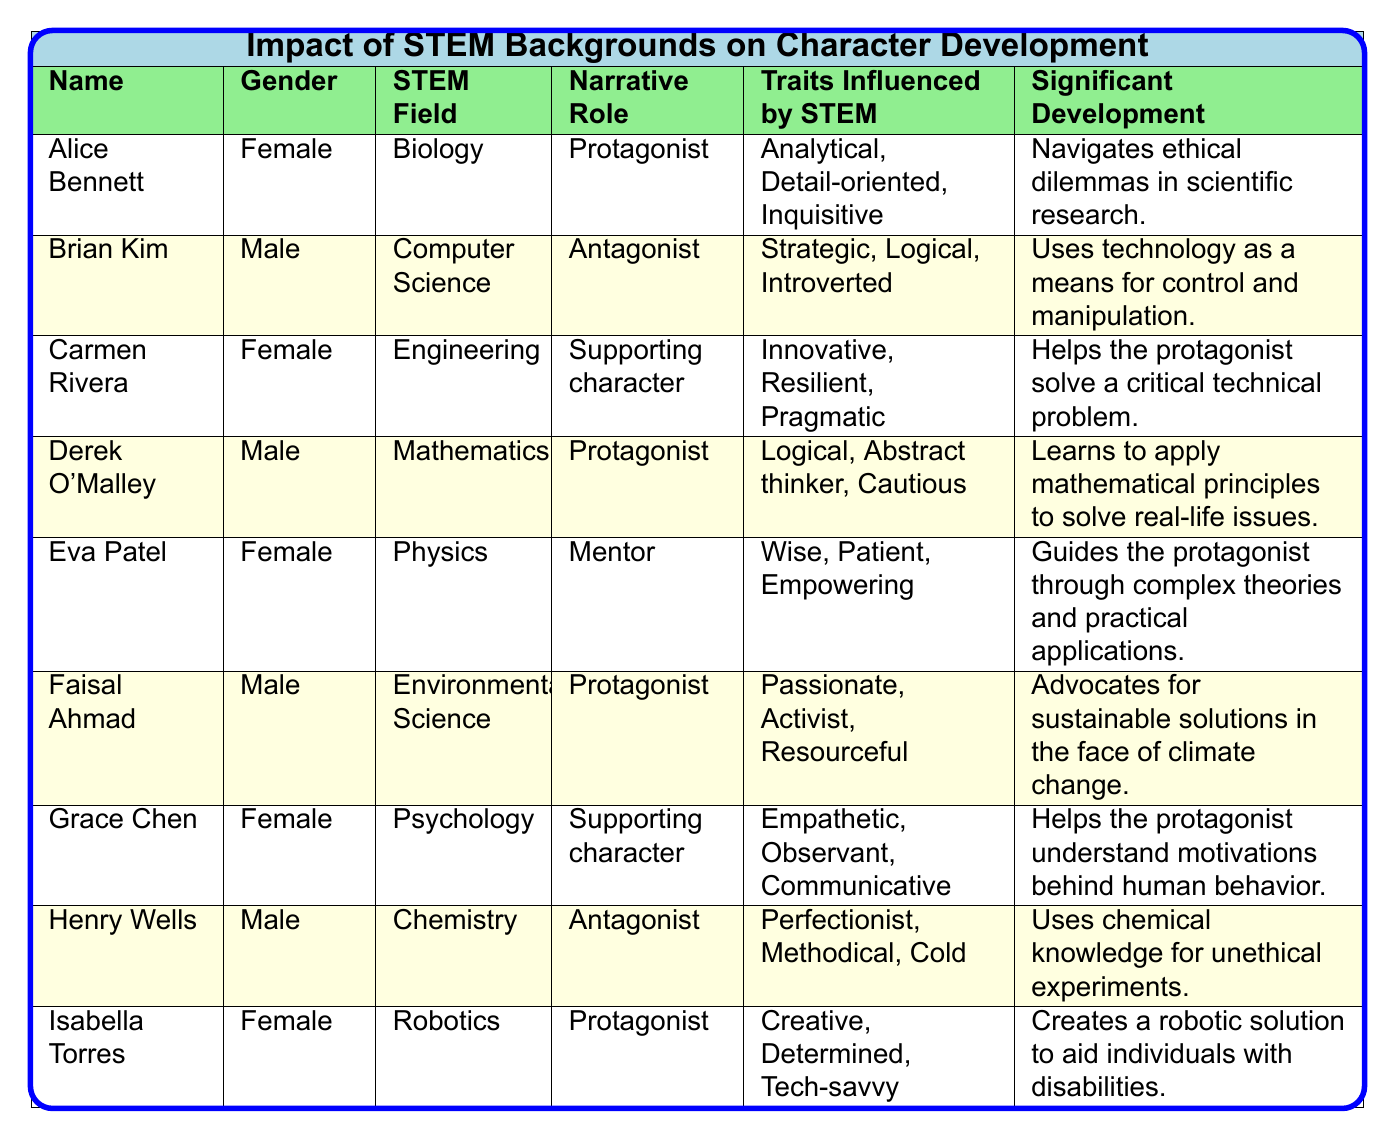What is the STEM field of Alice Bennett? Alice Bennett's STEM field is listed directly in the table under the "STEM Field" column next to her name.
Answer: Biology How many female characters are protagonists? By examining the table, we see Alice Bennett, Derek O'Malley, Faisal Ahmad, and Isabella Torres are categorized as protagonists. Among these, Alice Bennett and Isabella Torres are female, making a total of 2 female protagonists.
Answer: 2 Which character is described as having traits influenced by being strategic, logical, and introverted? The table shows that Brian Kim has the traits "Strategic, Logical, Introverted," found in the "Traits Influenced by STEM" column that corresponds to his name in the first column.
Answer: Brian Kim What is the significant development for Carmen Rivera? Carmen Rivera's significant development is directly listed in the table, providing an explanation of how she helps the protagonist solve a critical technical problem.
Answer: Helps the protagonist solve a critical technical problem Which character has the STEM field of Chemistry? The table indicates that Henry Wells is associated with the STEM field of Chemistry, as per the "STEM Field" column next to his name.
Answer: Henry Wells Are there more female characters than male characters in total? Counting the characters in the table, there are 5 females (Alice, Carmen, Eva, Grace, Isabella) and 4 males (Brian, Derek, Faisal, Henry), which means there are more females than males.
Answer: Yes What is the ratio of protagonists to antagonists in this table? There are 4 protagonists (Alice, Derek, Faisal, Isabella) and 3 antagonists (Brian, Henry). To find the ratio, we can express it as a fraction: 4 protagonists / 3 antagonists.
Answer: 4:3 Which character acts as a mentor? Eva Patel is designated as a mentor in the table, as indicated in the "Narrative Role" column.
Answer: Eva Patel What traits does Isla Torres have? The table describes Isabella Torres as having "Creative, Determined, Tech-savvy," which can be found in the "Traits Influenced by STEM" column next to her name.
Answer: Creative, Determined, Tech-savvy List the STEM fields of all protagonists in alphabetical order. The protagonists are Alice (Biology), Derek (Mathematics), Faisal (Environmental Science), and Isabella (Robotics). Alphabetically, the order is: Biology, Environmental Science, Mathematics, Robotics.
Answer: Biology, Environmental Science, Mathematics, Robotics What is the primary role of Eva Patel in the narrative? Eva Patel's narrative role is clearly listed in the table as "Mentor," showing her position relative to other characters.
Answer: Mentor 